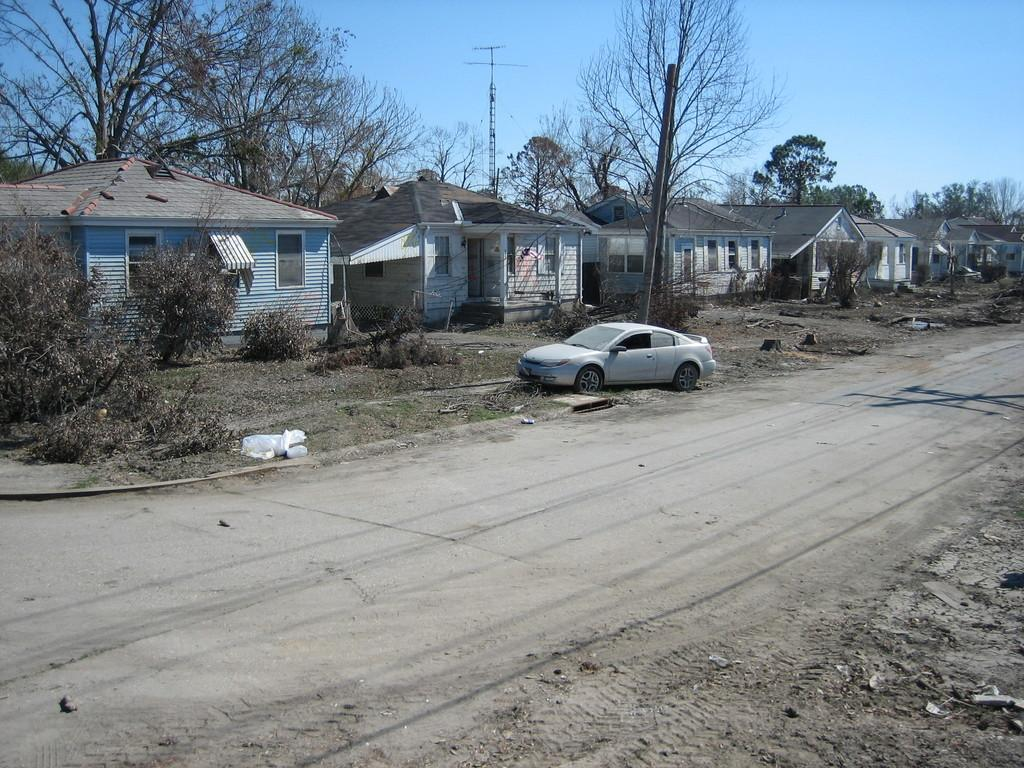What type of structures can be seen in the image? There are houses in the image. What type of vegetation is present in the image? There are trees and plants in the image. What mode of transportation can be seen in the image? There is a vehicle in the image. What is the surface on which the houses, trees, and plants are situated? There is ground visible in the image. What objects are placed on the ground in the image? There are objects on the ground in the image. What vertical structures can be seen in the image? There are poles in the image. What part of the natural environment is visible in the image? The sky is visible in the image. Can you tell me how many rifles are hidden in the trees in the image? There are no rifles present in the image; it features houses, trees, plants, a vehicle, ground, objects on the ground, poles, and the sky. Is there a bomb visible in the image? There is no bomb present in the image. 